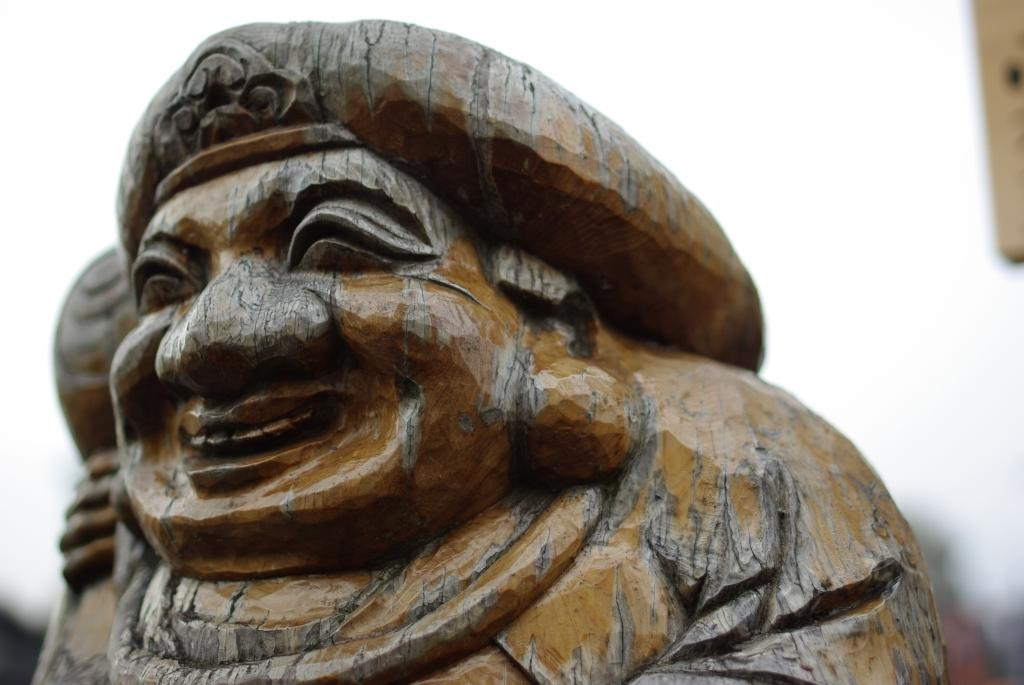What is the main subject in the image? There is a statue in the image. What type of stitch is used to create the statue's clothing in the image? The image does not depict a statue being created, nor does it show any stitching or clothing on the statue. 